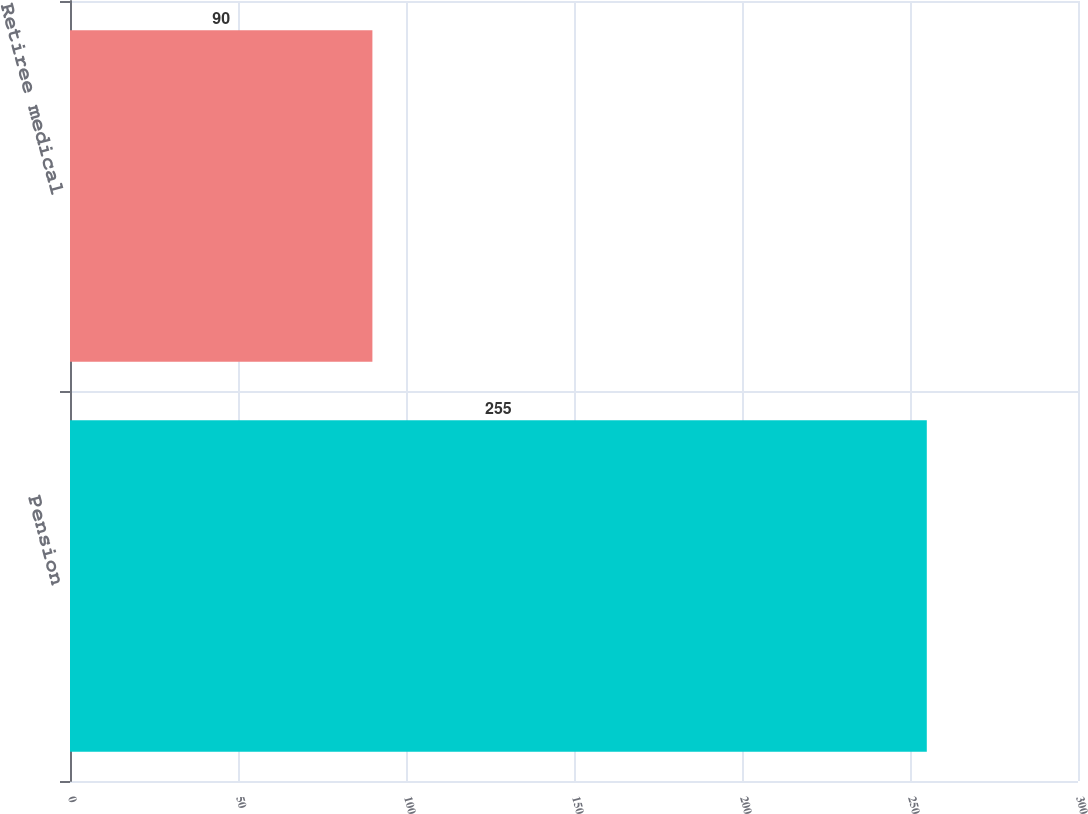Convert chart. <chart><loc_0><loc_0><loc_500><loc_500><bar_chart><fcel>Pension<fcel>Retiree medical<nl><fcel>255<fcel>90<nl></chart> 